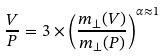<formula> <loc_0><loc_0><loc_500><loc_500>\frac { V } { P } = 3 \times \left ( \frac { m _ { \perp } ( V ) } { m _ { \perp } ( P ) } \right ) ^ { \alpha \approx 1 }</formula> 